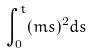<formula> <loc_0><loc_0><loc_500><loc_500>\int _ { 0 } ^ { t } ( m s ) ^ { 2 } d s</formula> 